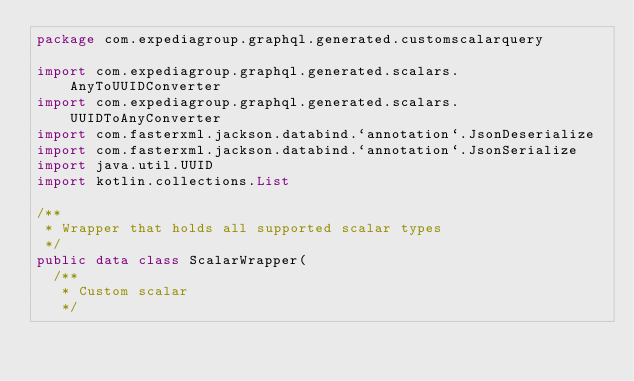Convert code to text. <code><loc_0><loc_0><loc_500><loc_500><_Kotlin_>package com.expediagroup.graphql.generated.customscalarquery

import com.expediagroup.graphql.generated.scalars.AnyToUUIDConverter
import com.expediagroup.graphql.generated.scalars.UUIDToAnyConverter
import com.fasterxml.jackson.databind.`annotation`.JsonDeserialize
import com.fasterxml.jackson.databind.`annotation`.JsonSerialize
import java.util.UUID
import kotlin.collections.List

/**
 * Wrapper that holds all supported scalar types
 */
public data class ScalarWrapper(
  /**
   * Custom scalar
   */</code> 